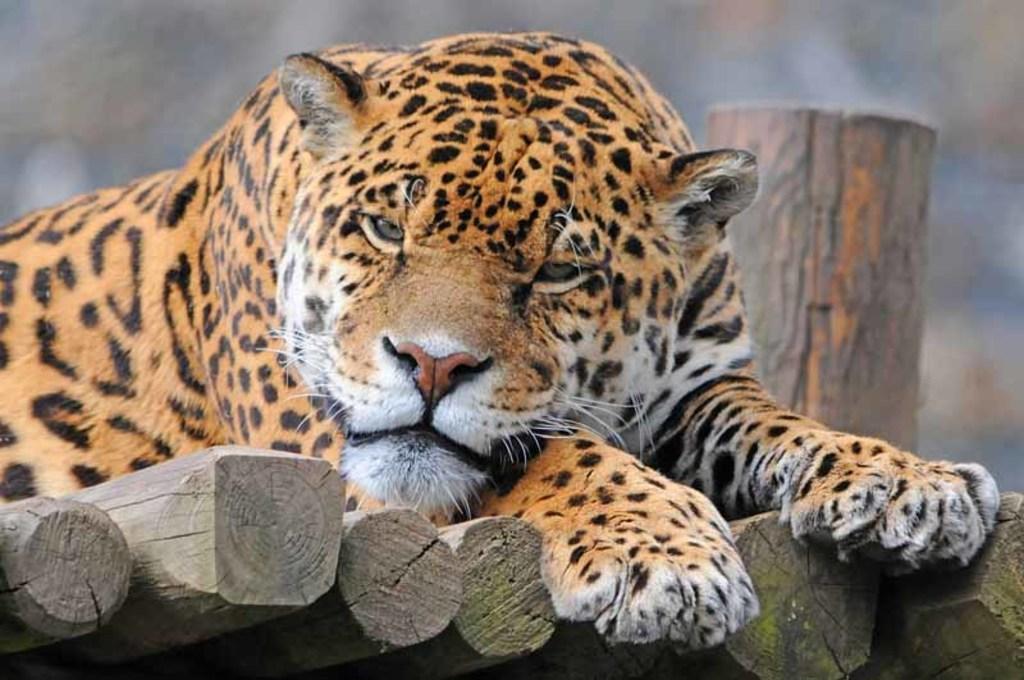Could you give a brief overview of what you see in this image? In this image we can see a tiger on the wooden poles, and the background is blurred. 